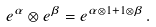Convert formula to latex. <formula><loc_0><loc_0><loc_500><loc_500>e ^ { \alpha } \otimes e ^ { \beta } = e ^ { \alpha \otimes 1 + 1 \otimes \beta } \, .</formula> 